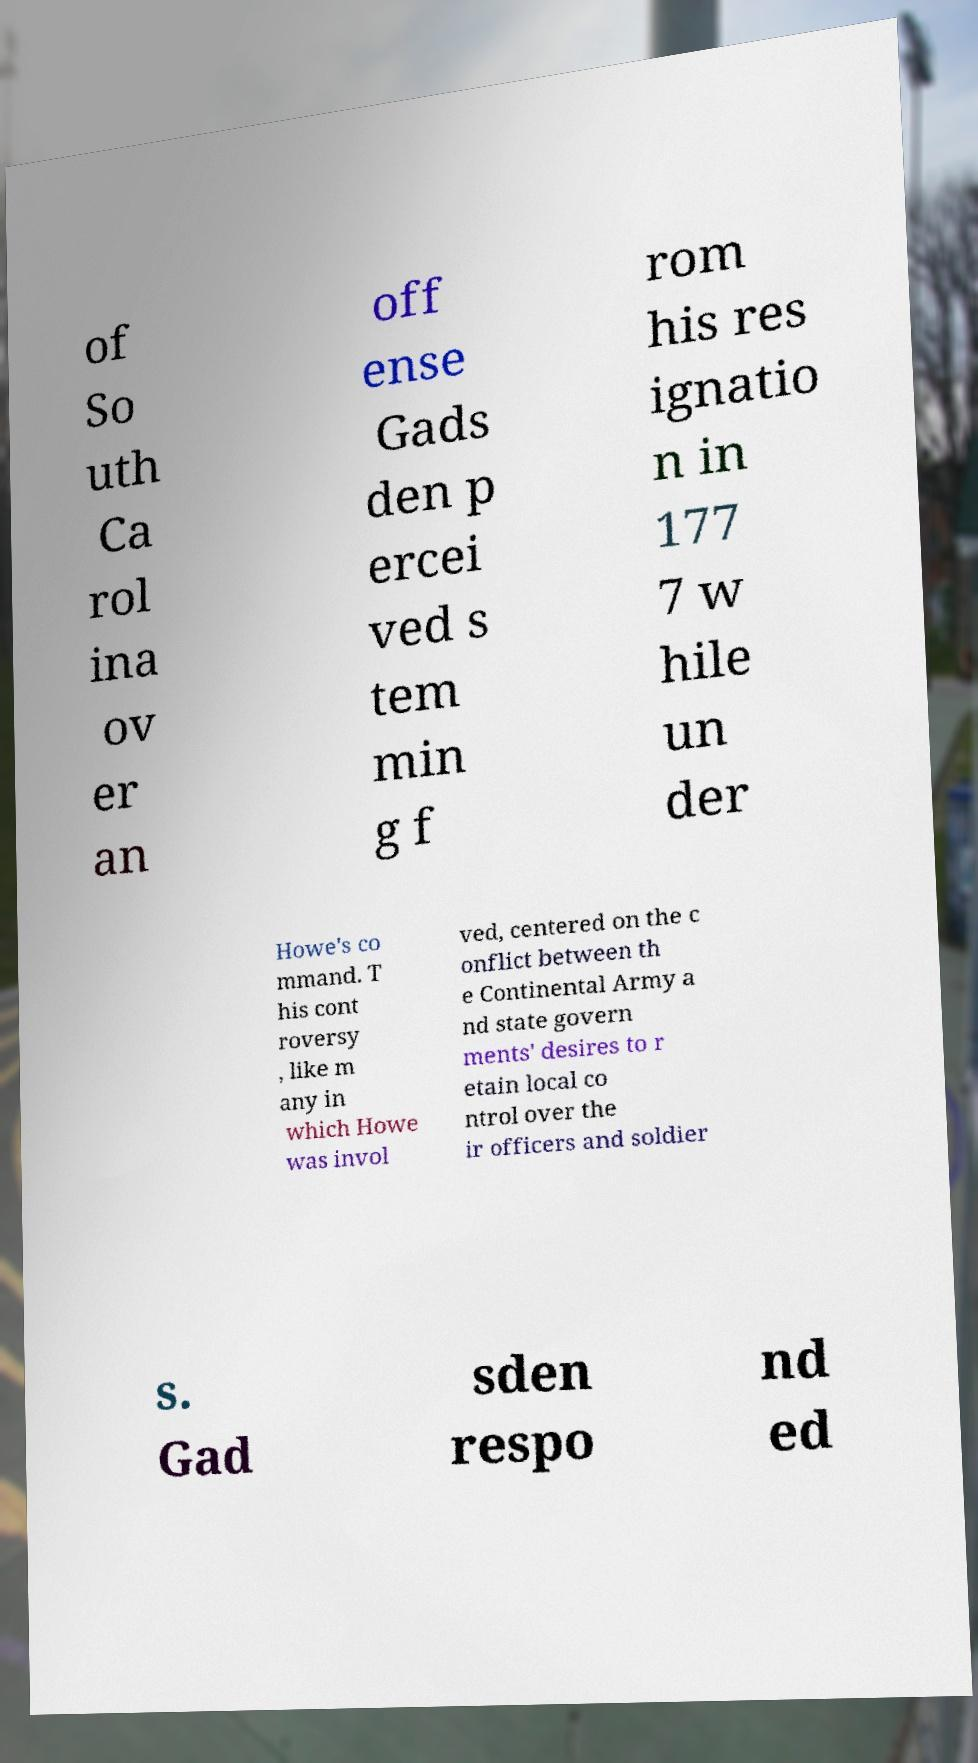There's text embedded in this image that I need extracted. Can you transcribe it verbatim? of So uth Ca rol ina ov er an off ense Gads den p ercei ved s tem min g f rom his res ignatio n in 177 7 w hile un der Howe's co mmand. T his cont roversy , like m any in which Howe was invol ved, centered on the c onflict between th e Continental Army a nd state govern ments' desires to r etain local co ntrol over the ir officers and soldier s. Gad sden respo nd ed 